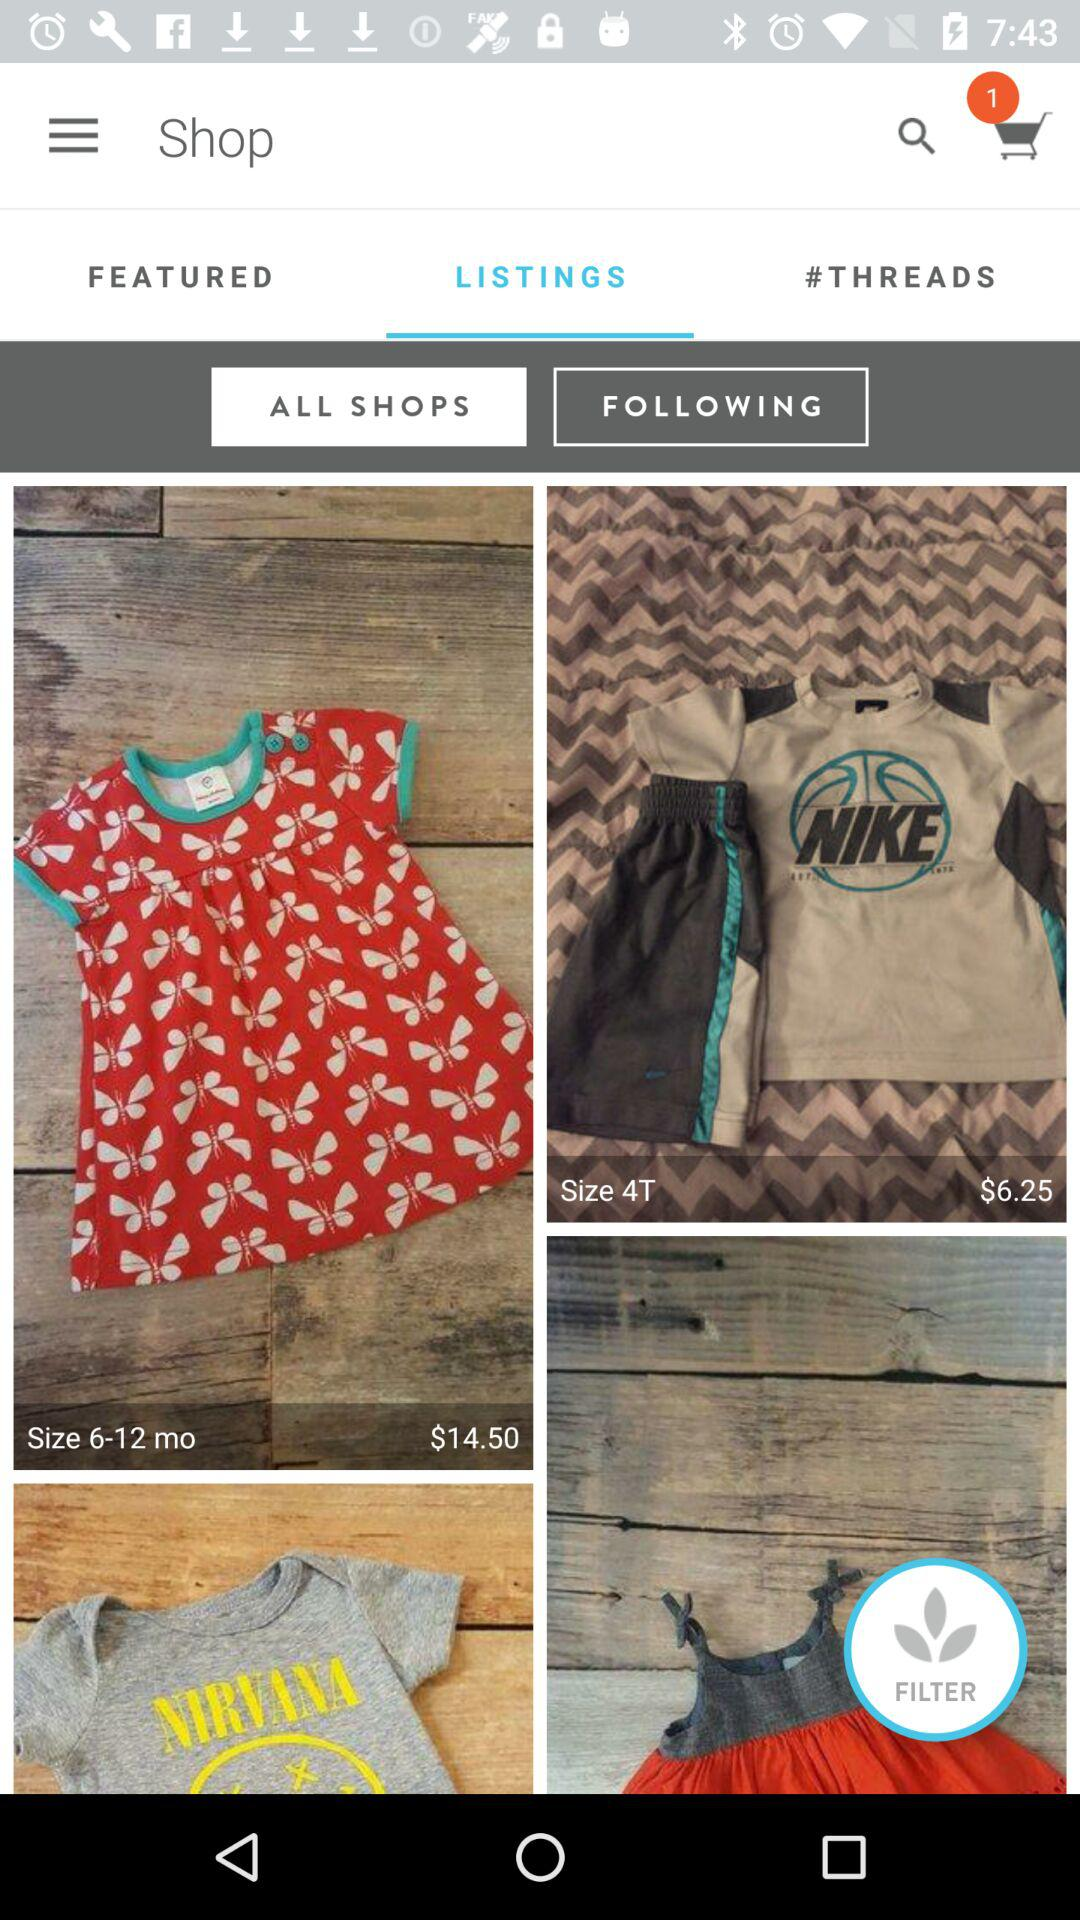What is the price of the cloth whose size is 6–12 months? The price of the cloth, whose size is 6–12 months, is $14.50. 